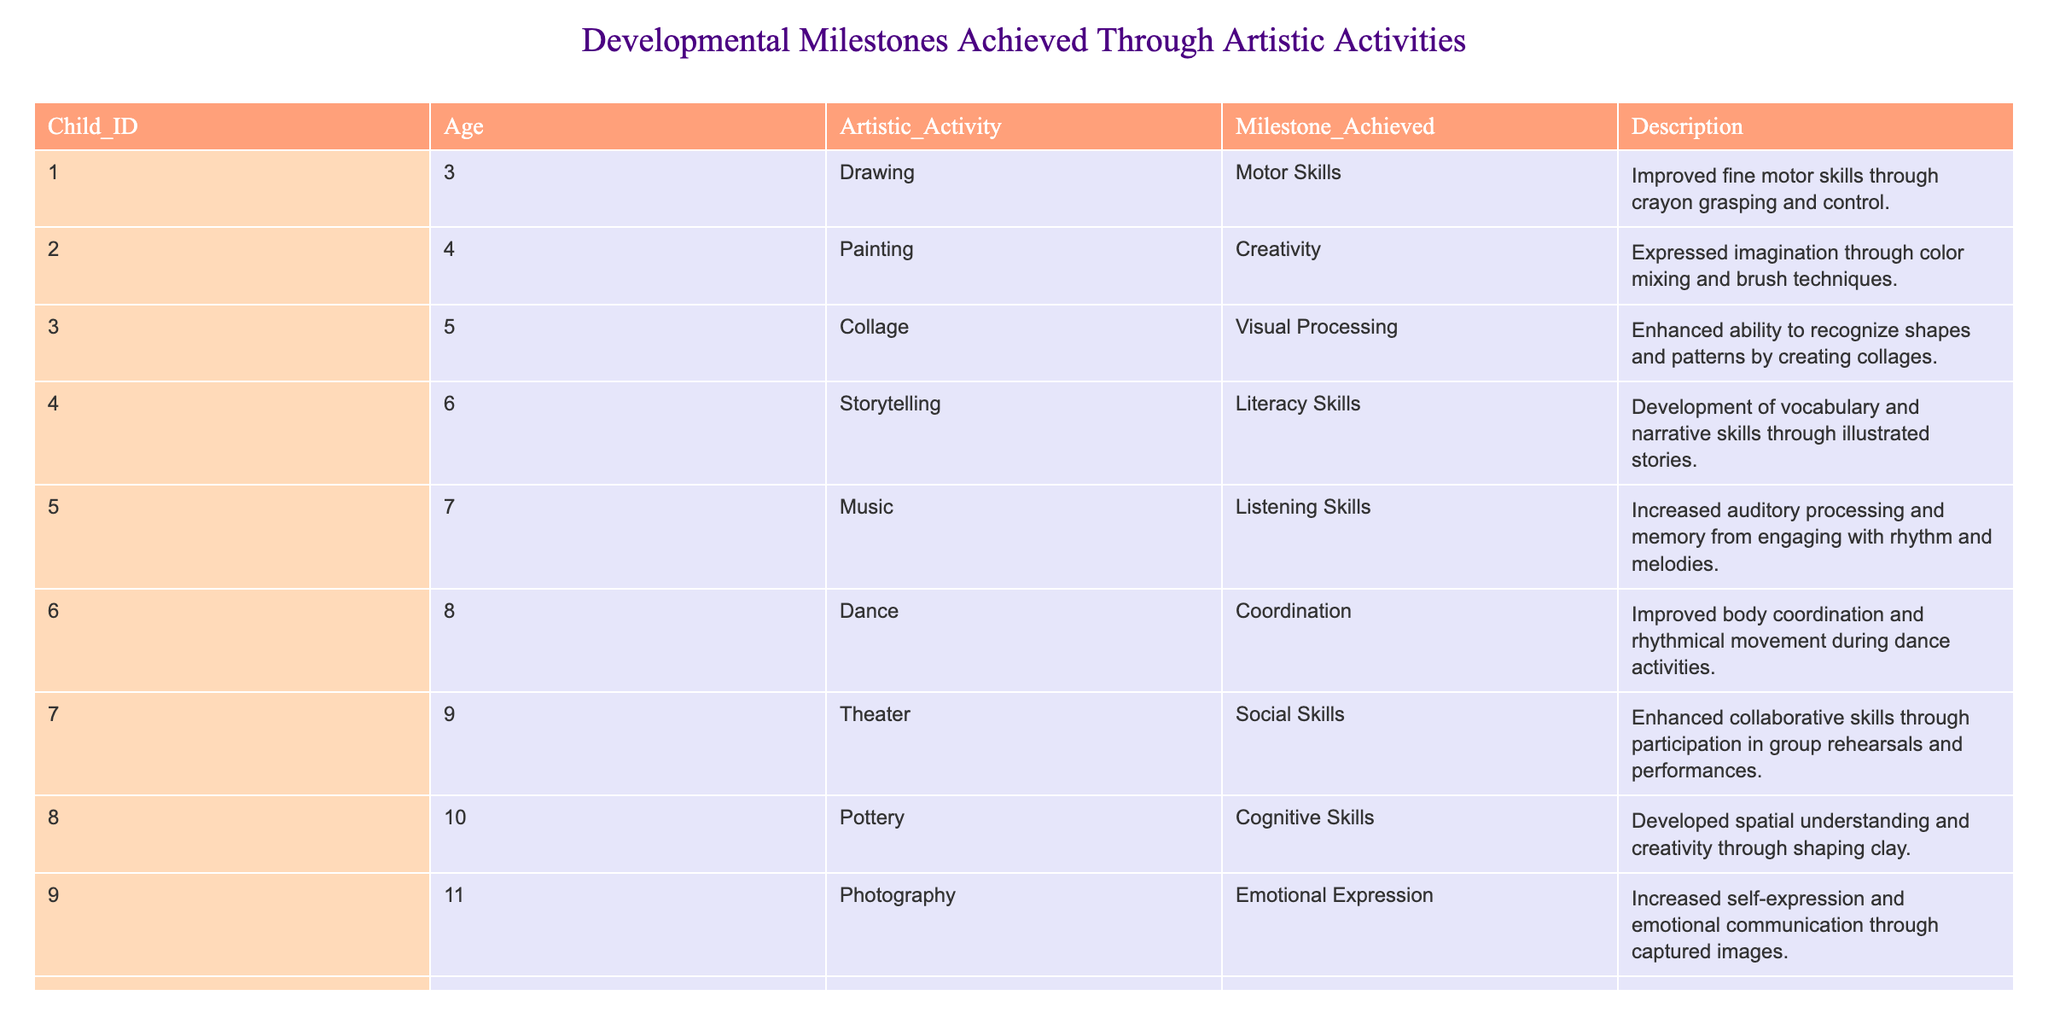What's the milestone achieved by the child who participated in drawing activities? The table lists that the child engaged in drawing activity achieved the Motor Skills milestone. Specifically, this is mentioned in the row where Artistic Activity is "Drawing."
Answer: Motor Skills What age group primarily engages in music activities according to the data? Based on the table, the child who participated in music activities is 7 years old, as indicated in the row where Artistic Activity is "Music."
Answer: 7 years old How many children achieved social skills through theater? From the table, there is one child (Child_ID 007) who achieved social skills through participating in theater activities. The relevant row indicates this clearly.
Answer: 1 child What is the average age of children who achieved cognitive skills through artistic activities? Examining the table, only one child (Child_ID 008) achieved cognitive skills and is 10 years old. Since there is only one child, the average age is that child's age itself.
Answer: 10 years old Did any child reach literacy skills through storytelling activities? The table confirms that there is one child (Child_ID 004) who achieved literacy skills by engaging in storytelling activities. The respective row supports this fact.
Answer: Yes Which artistic activity contributed to listening skills, and at what age? The table indicates that music activities contributed to listening skills for a child who is 7 years old (Child_ID 005). The respective row specifies this information.
Answer: Music at 7 years old Which artistic activity is associated with enhanced creative expression through the use of colors? The activity of painting is associated with creativity, as noted in the table, particularly in the row for Child_ID 002 who is 4 years old.
Answer: Painting How many activities reported improvements in fine motor skills or coordination? The table outlines fine motor skills achieved through drawing activities (Child_ID 001) and coordination through dance activities (Child_ID 006). This sums up to two activities in total.
Answer: 2 activities What cognitive skill was developed by the child who engaged in sculpture? According to the table, the sculpture activity contributed to problem-solving skills for a child who is 12 years old (Child_ID 010). This is directly referenced in the appropriate row.
Answer: Problem-solving skills 